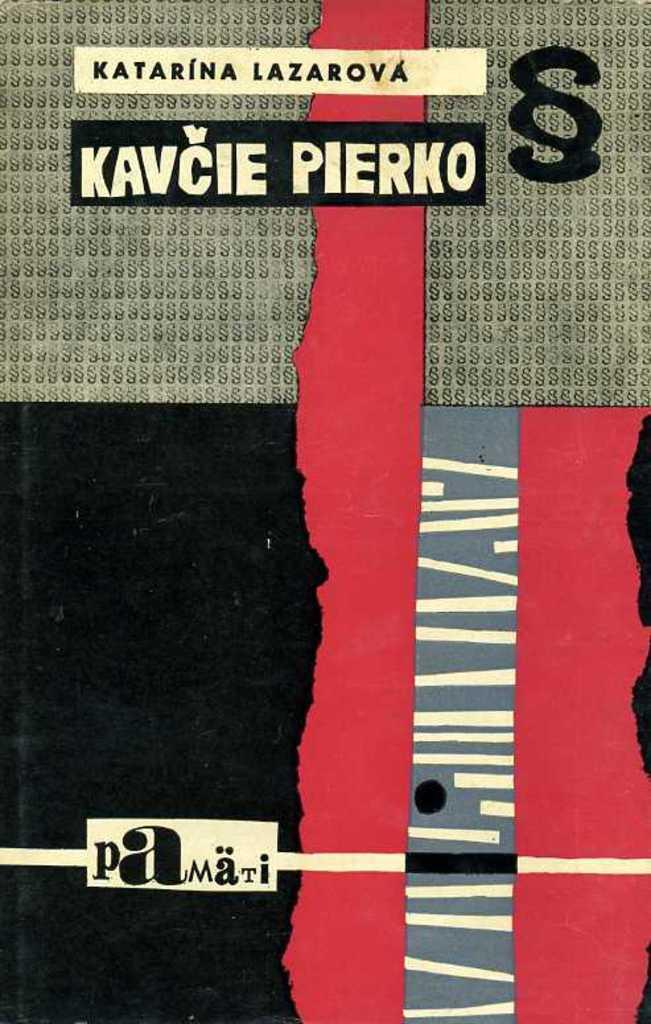What is present on the poster in the image? There is a poster in the image. What can be seen on the poster besides its design? There is text written on the poster. Can the poster in the image whistle a tune? The poster in the image cannot whistle a tune, as it is an inanimate object. 